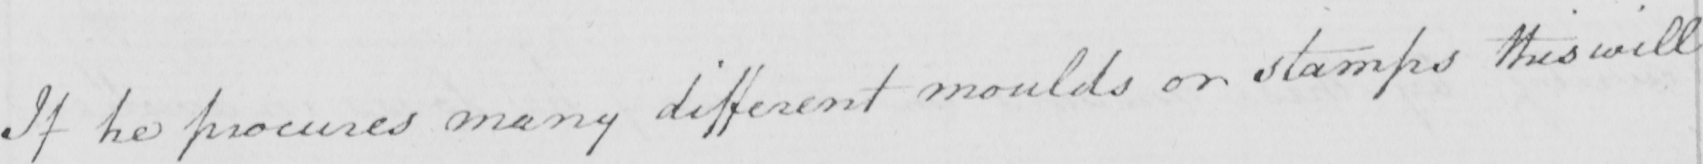What text is written in this handwritten line? If he procures many different moulds or stamps this will 